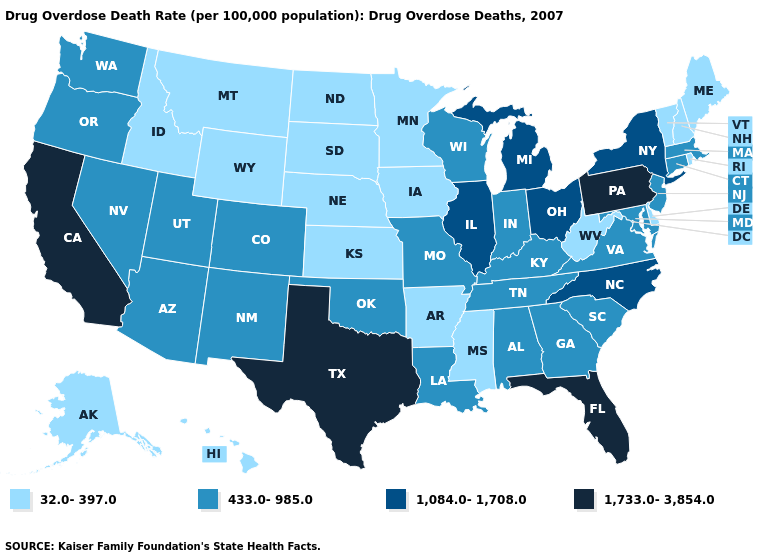What is the value of Ohio?
Short answer required. 1,084.0-1,708.0. Name the states that have a value in the range 1,084.0-1,708.0?
Quick response, please. Illinois, Michigan, New York, North Carolina, Ohio. Does the first symbol in the legend represent the smallest category?
Write a very short answer. Yes. What is the highest value in the USA?
Short answer required. 1,733.0-3,854.0. What is the lowest value in states that border Wyoming?
Write a very short answer. 32.0-397.0. Does Florida have the highest value in the USA?
Give a very brief answer. Yes. What is the value of Ohio?
Quick response, please. 1,084.0-1,708.0. What is the value of North Dakota?
Write a very short answer. 32.0-397.0. What is the value of Washington?
Keep it brief. 433.0-985.0. Is the legend a continuous bar?
Answer briefly. No. Does Kentucky have the highest value in the USA?
Keep it brief. No. Among the states that border Arizona , does California have the lowest value?
Short answer required. No. Name the states that have a value in the range 1,084.0-1,708.0?
Be succinct. Illinois, Michigan, New York, North Carolina, Ohio. Name the states that have a value in the range 433.0-985.0?
Give a very brief answer. Alabama, Arizona, Colorado, Connecticut, Georgia, Indiana, Kentucky, Louisiana, Maryland, Massachusetts, Missouri, Nevada, New Jersey, New Mexico, Oklahoma, Oregon, South Carolina, Tennessee, Utah, Virginia, Washington, Wisconsin. Does New Mexico have a higher value than Alaska?
Concise answer only. Yes. 